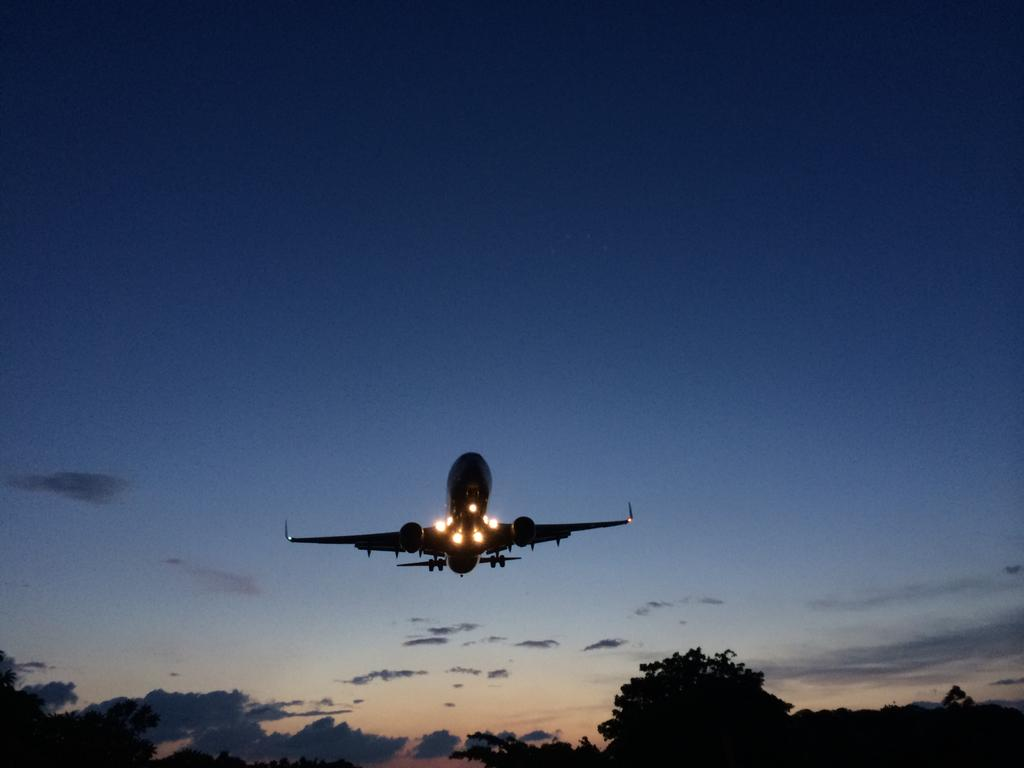What is the main subject of the image? The main subject of the image is an airplane. What is the airplane doing in the image? The airplane is flying. What can be seen under the airplane? There are trees under the airplane. What is visible behind the airplane? The sky is visible behind the airplane. What type of cloth is being used to catch the wren in the image? There is no wren or cloth present in the image; it features an airplane flying over trees with the sky visible in the background. 